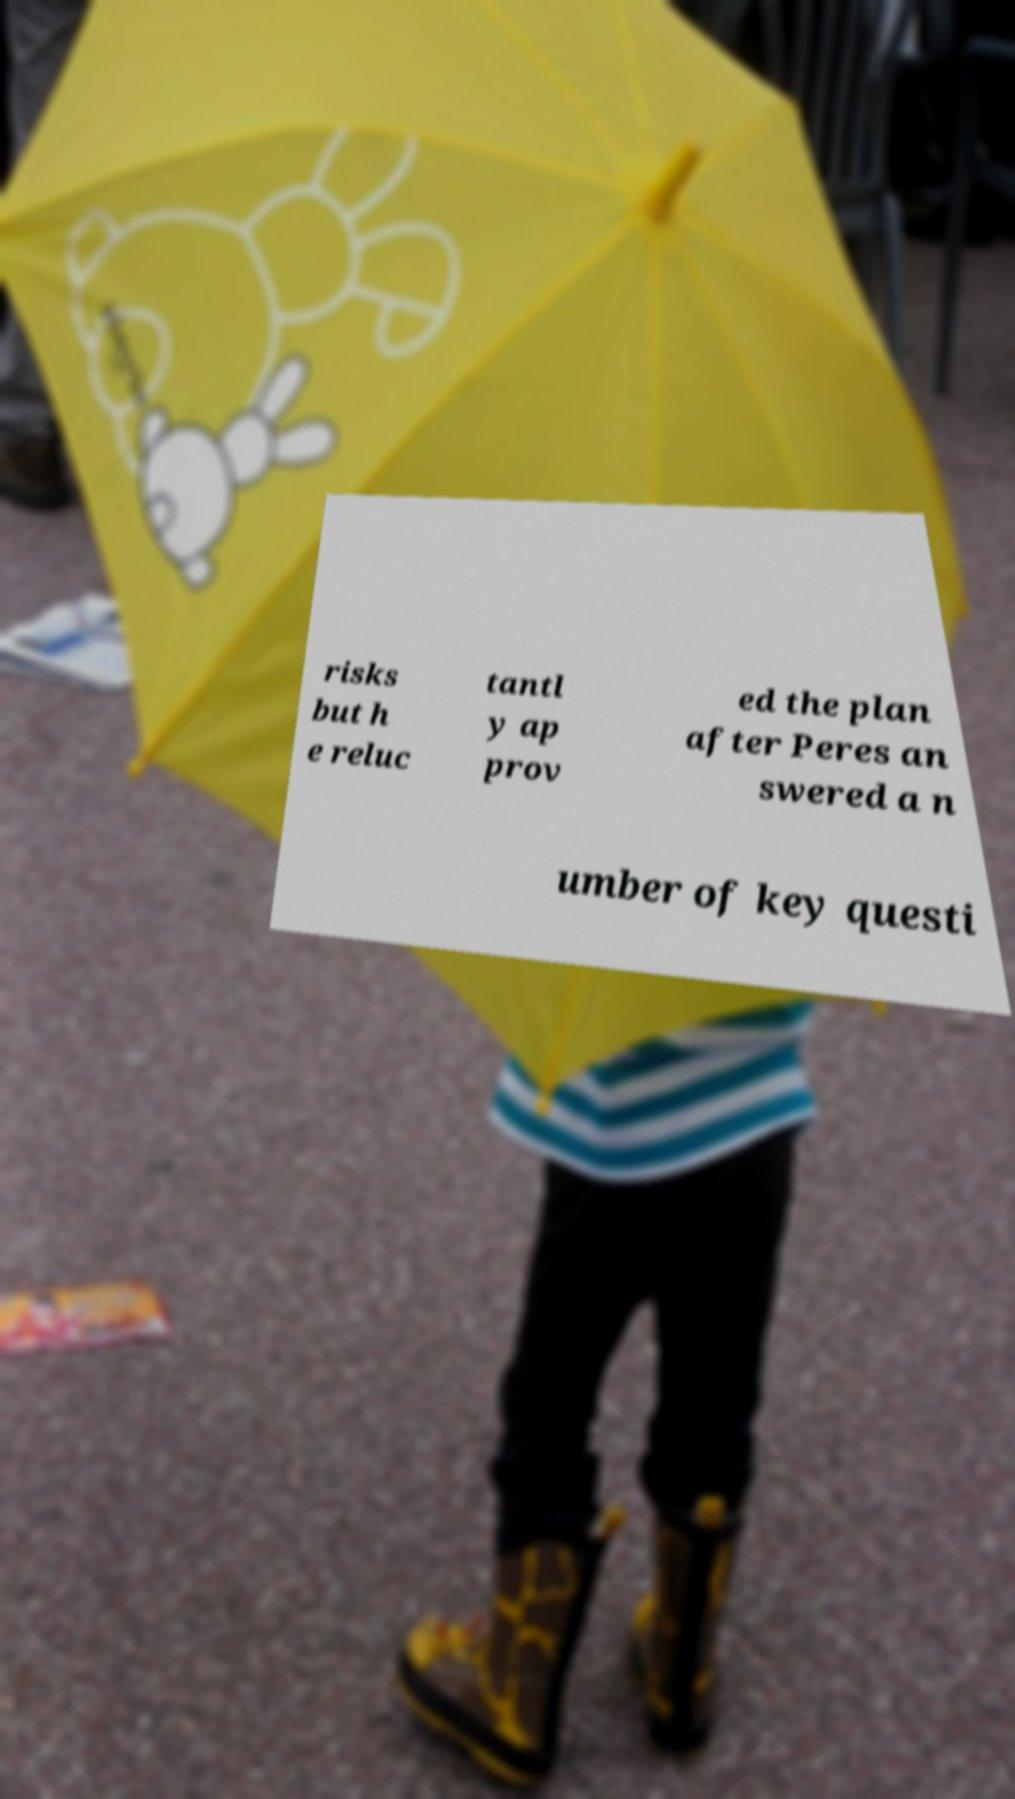Please identify and transcribe the text found in this image. risks but h e reluc tantl y ap prov ed the plan after Peres an swered a n umber of key questi 